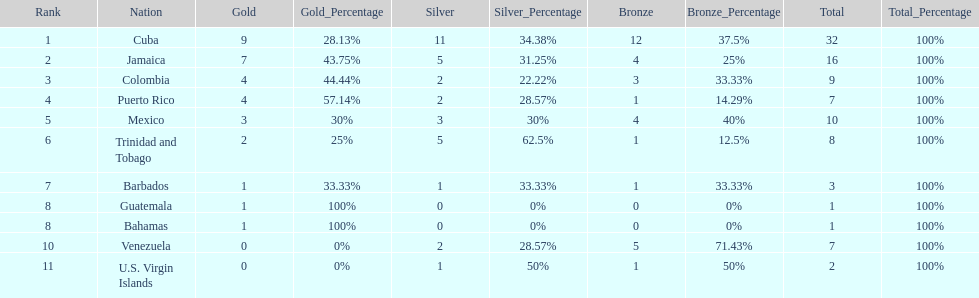Nations that had 10 or more medals each Cuba, Jamaica, Mexico. 